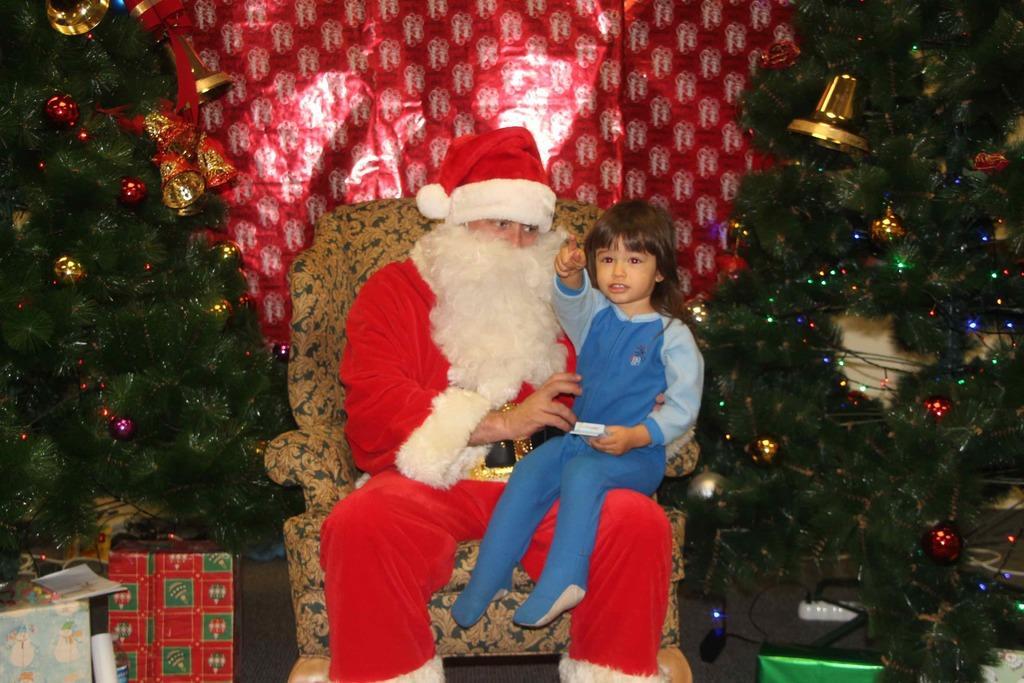Please provide a concise description of this image. In the center of the image we can see one person is sitting on the chair and he is in red and white color costume. And we can see he is holding one kid. And we can see the kid is holding some object. In the background there is a curtain, x-mas trees, gift boxes and a few other objects. And we can see some decorative items on the x-mas trees. 